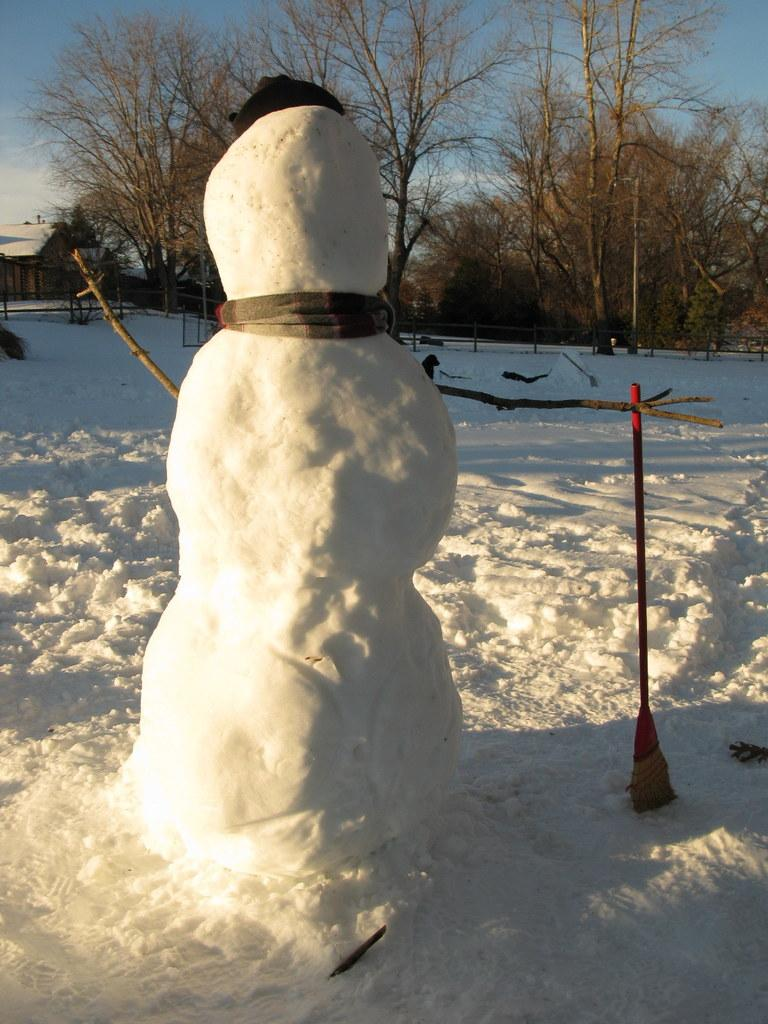What is the main subject in the image? There is a snowman in the image. What can be seen in the background of the image? There are trees and a house in the background of the image. What is visible in the sky in the image? The sky is visible in the background of the image. What type of afterthought can be seen in the image? There is no afterthought present in the image. Can you see any goldfish swimming in the image? There are no goldfish present in the image. What type of leather material is visible in the image? There is no leather material present in the image. 